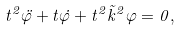Convert formula to latex. <formula><loc_0><loc_0><loc_500><loc_500>t ^ { 2 } \ddot { \varphi } + t \dot { \varphi } + t ^ { 2 } \vec { k } ^ { 2 } \varphi = 0 ,</formula> 